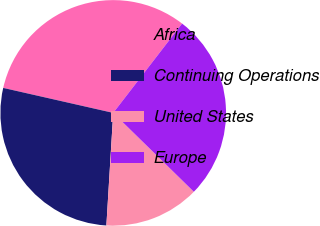Convert chart to OTSL. <chart><loc_0><loc_0><loc_500><loc_500><pie_chart><fcel>Africa<fcel>Continuing Operations<fcel>United States<fcel>Europe<nl><fcel>31.9%<fcel>27.59%<fcel>13.64%<fcel>26.87%<nl></chart> 